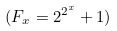Convert formula to latex. <formula><loc_0><loc_0><loc_500><loc_500>( F _ { x } = 2 ^ { 2 ^ { x } } + 1 )</formula> 